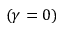<formula> <loc_0><loc_0><loc_500><loc_500>( \gamma = 0 )</formula> 